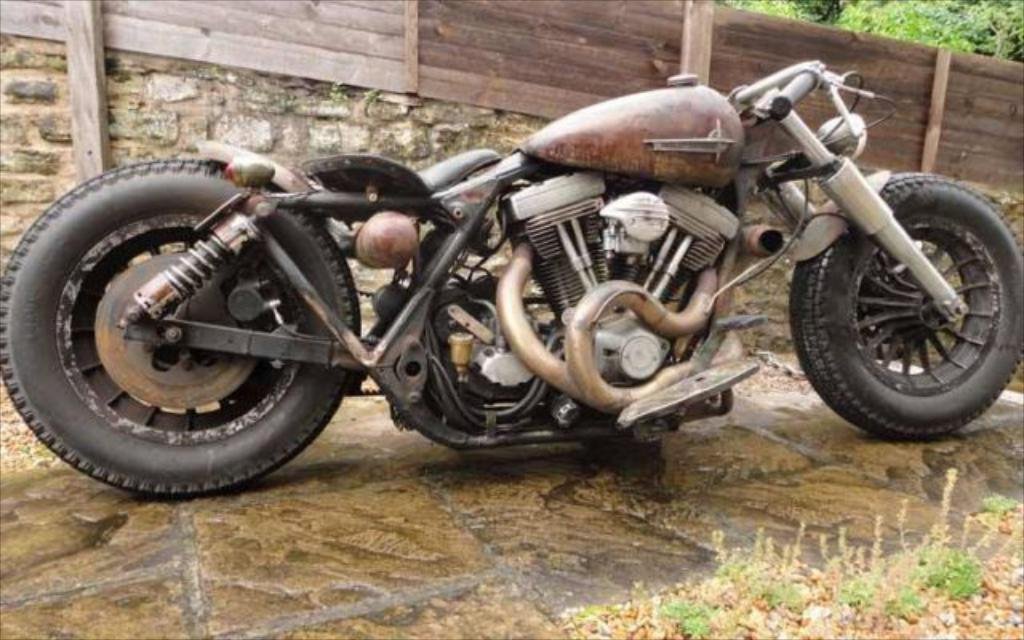What is the main subject in the center of the image? There is a bike in the center of the image. What can be seen in the background of the image? There is a fence and trees in the background of the image. Where is the oven located in the image? There is no oven present in the image. What type of brush can be seen being used by the trees in the image? There are no brushes or tree-related activities depicted in the image. 